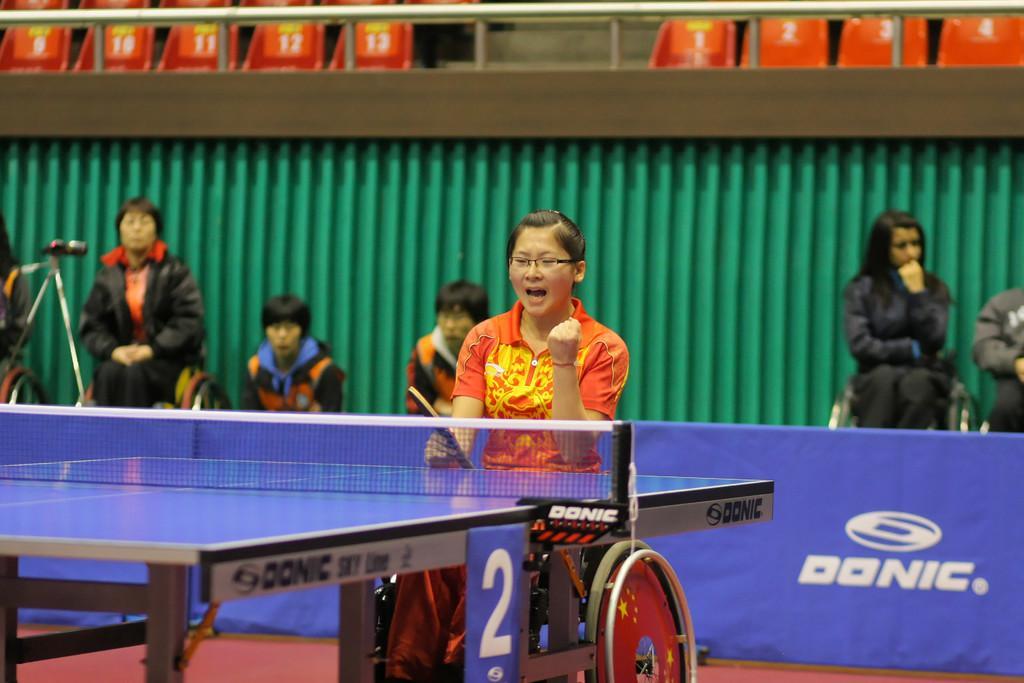How would you summarize this image in a sentence or two? In the front of the image there is woman in the wheelchair and she is holding a table tennis bat. She wore a orange jersey and spectacles. Just in front of her there is table tennis table. Behind her there are few people among them four are sitting on a wheel chair. There is a camera kept on tripod stand. On top of the image there are chairs, steps and railing. Below of the image there is carpet and a banner with some text written on it.  